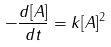<formula> <loc_0><loc_0><loc_500><loc_500>- \frac { d [ A ] } { d t } = k [ A ] ^ { 2 }</formula> 